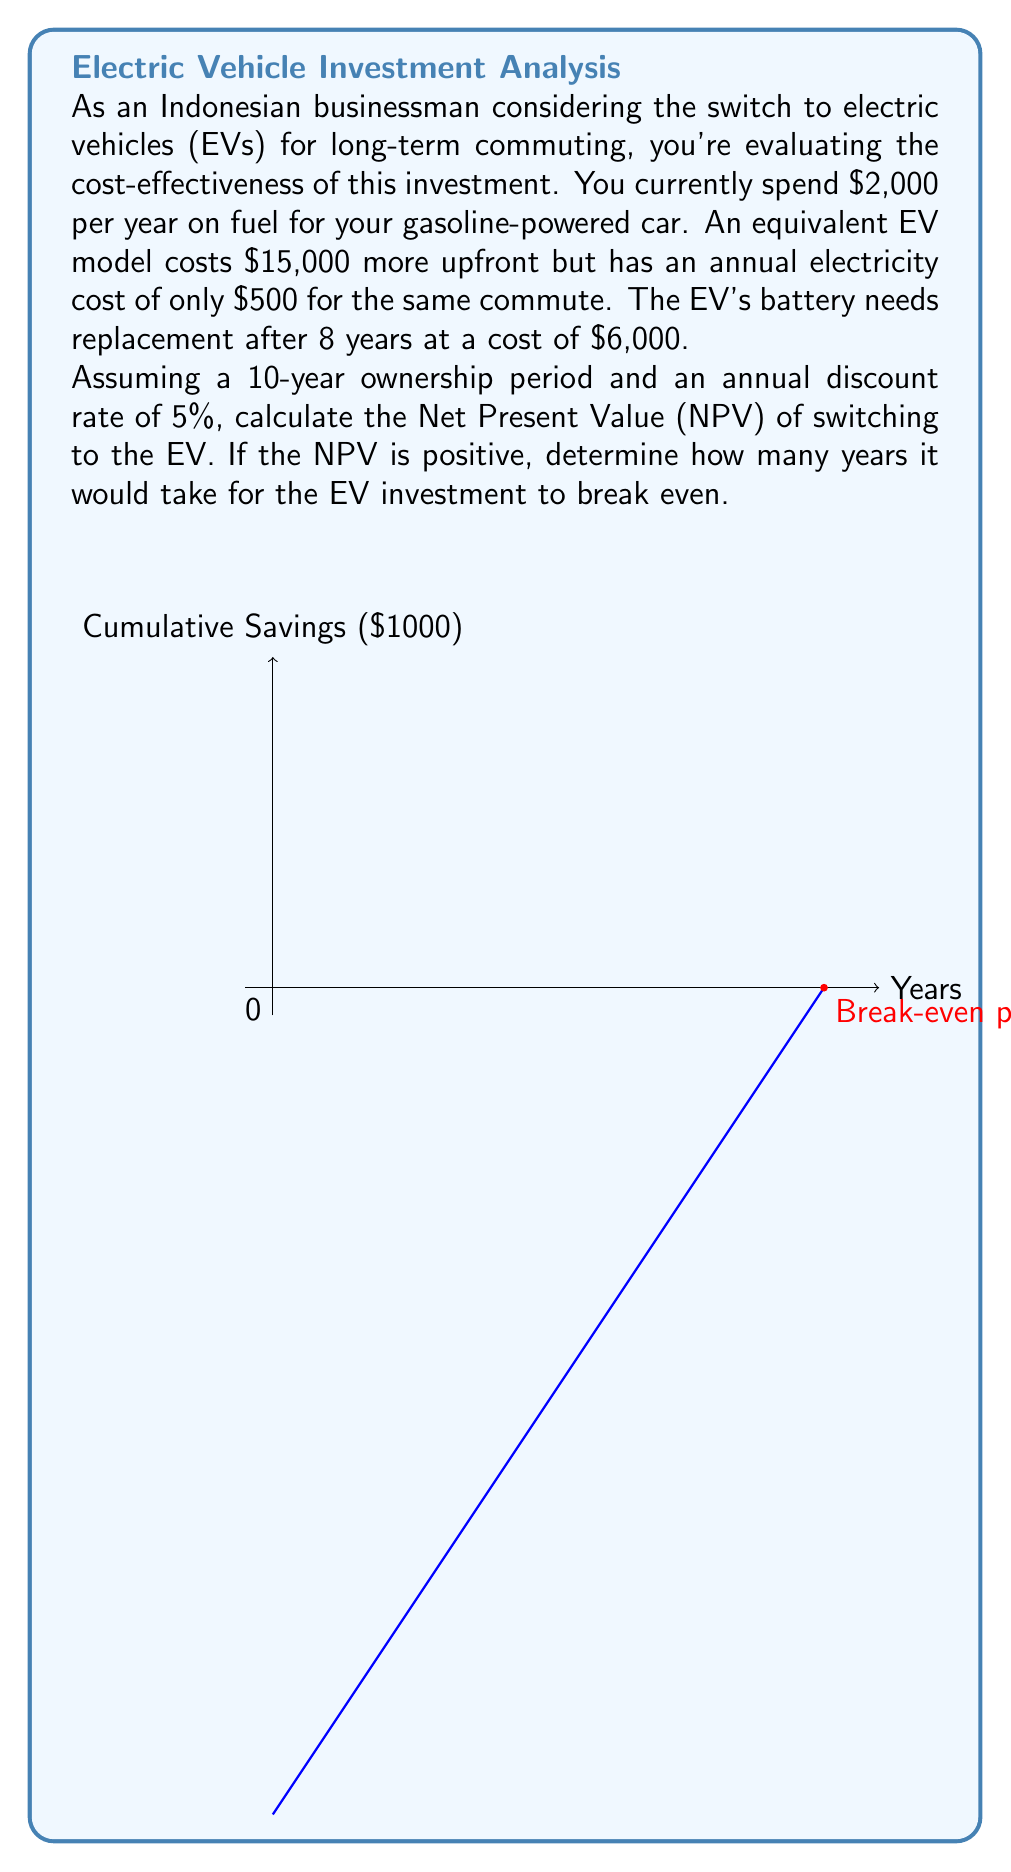What is the answer to this math problem? Let's approach this problem step-by-step:

1) First, calculate the annual savings from switching to EV:
   Annual savings = Gasoline cost - Electricity cost
   $$ 2000 - 500 = \$1500 $$

2) The NPV formula is:
   $$ NPV = -C_0 + \sum_{t=1}^{n} \frac{C_t}{(1+r)^t} $$
   Where $C_0$ is the initial cost, $C_t$ is the cash flow at time t, r is the discount rate, and n is the number of periods.

3) In this case:
   $C_0 = \$15,000$ (additional upfront cost)
   $C_t = \$1,500$ for years 1-7 and 9-10
   $C_8 = \$1,500 - \$6,000 = -\$4,500$ (due to battery replacement)
   $r = 5\% = 0.05$
   $n = 10$ years

4) Let's calculate the NPV:
   $$ NPV = -15000 + \sum_{t=1}^{7} \frac{1500}{(1.05)^t} + \frac{-4500}{(1.05)^8} + \frac{1500}{(1.05)^9} + \frac{1500}{(1.05)^{10}} $$

5) Using a financial calculator or spreadsheet, we get:
   $$ NPV \approx \$1,880.76 $$

6) Since the NPV is positive, the investment is cost-effective over the 10-year period.

7) To find the break-even point, we need to solve for t in:
   $$ 15000 = 1500 \times \sum_{t=1}^{t} \frac{1}{(1.05)^t} $$

8) Using trial and error or a financial calculator, we find that t ≈ 10 years.

The graph in the question illustrates the cumulative savings over time, with the break-even point occurring at approximately 10 years.
Answer: NPV ≈ $1,880.76; Break-even time ≈ 10 years 